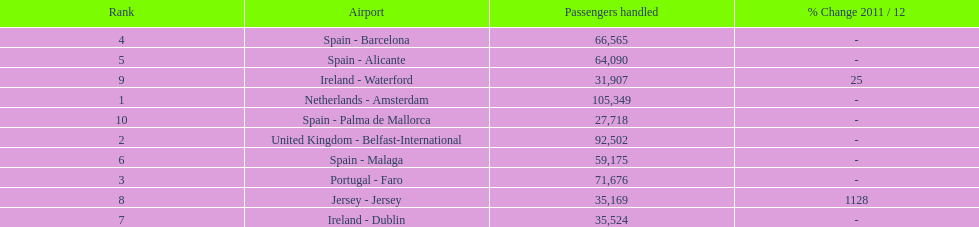How many passengers were handled in an airport in spain? 217,548. 